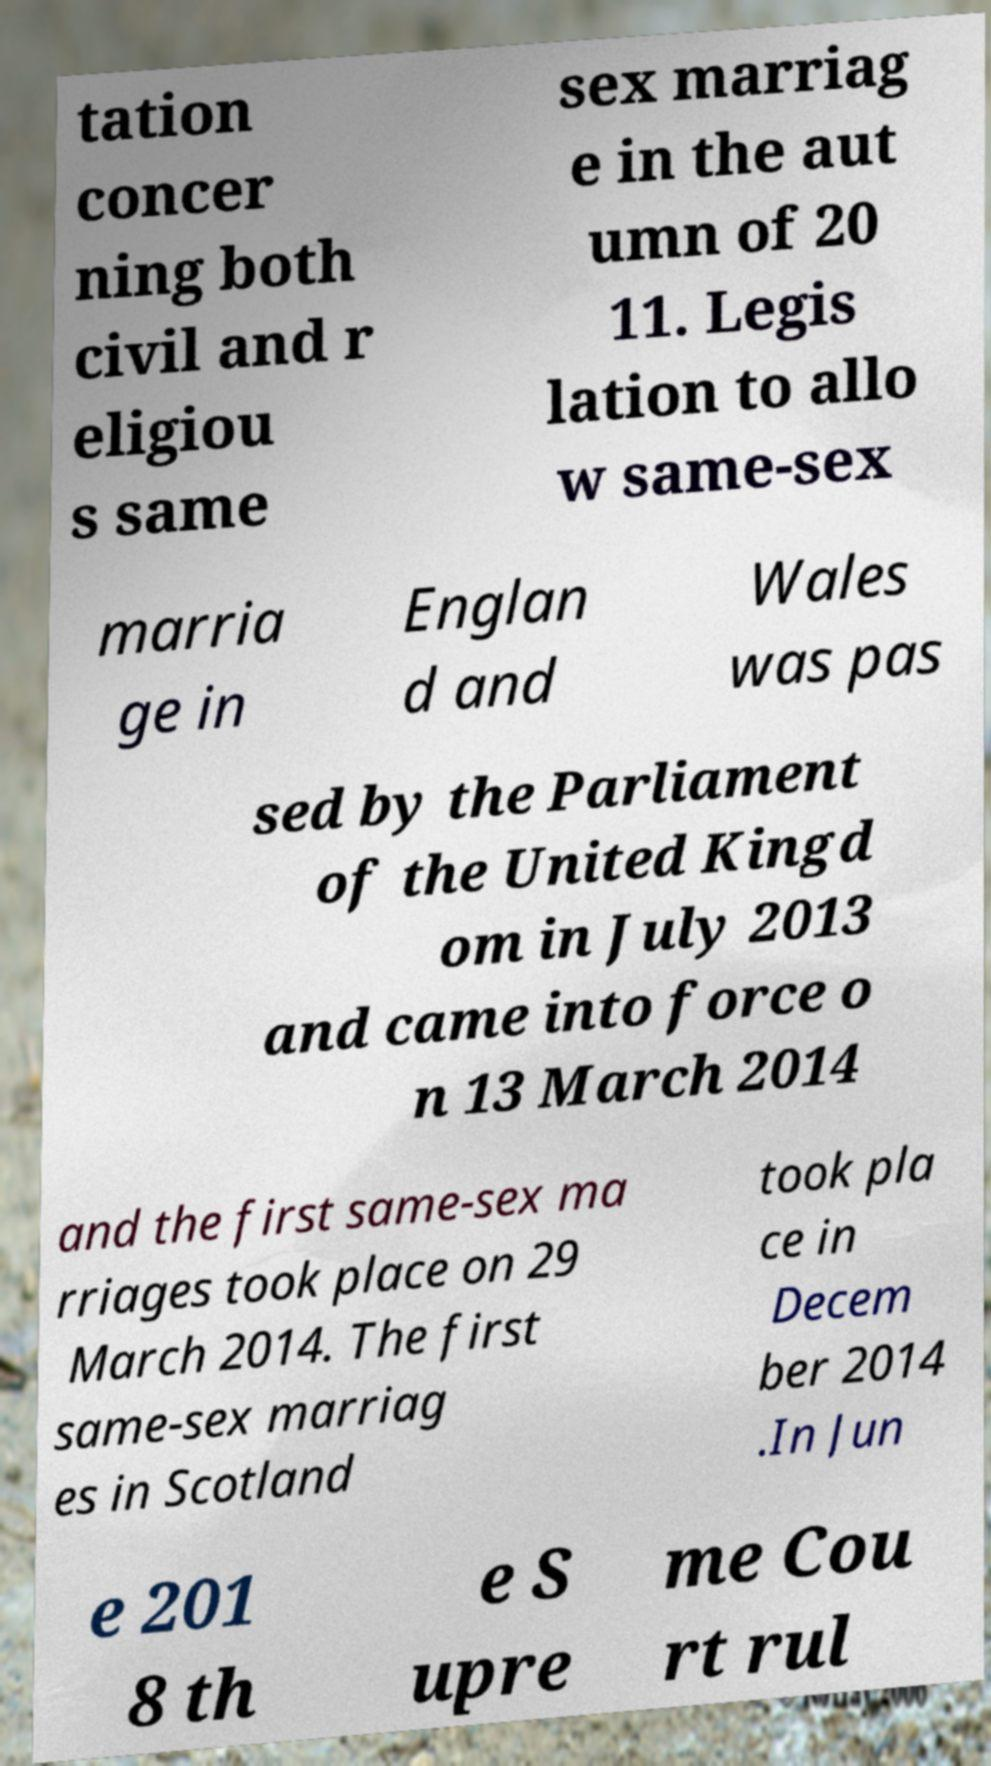There's text embedded in this image that I need extracted. Can you transcribe it verbatim? tation concer ning both civil and r eligiou s same sex marriag e in the aut umn of 20 11. Legis lation to allo w same-sex marria ge in Englan d and Wales was pas sed by the Parliament of the United Kingd om in July 2013 and came into force o n 13 March 2014 and the first same-sex ma rriages took place on 29 March 2014. The first same-sex marriag es in Scotland took pla ce in Decem ber 2014 .In Jun e 201 8 th e S upre me Cou rt rul 